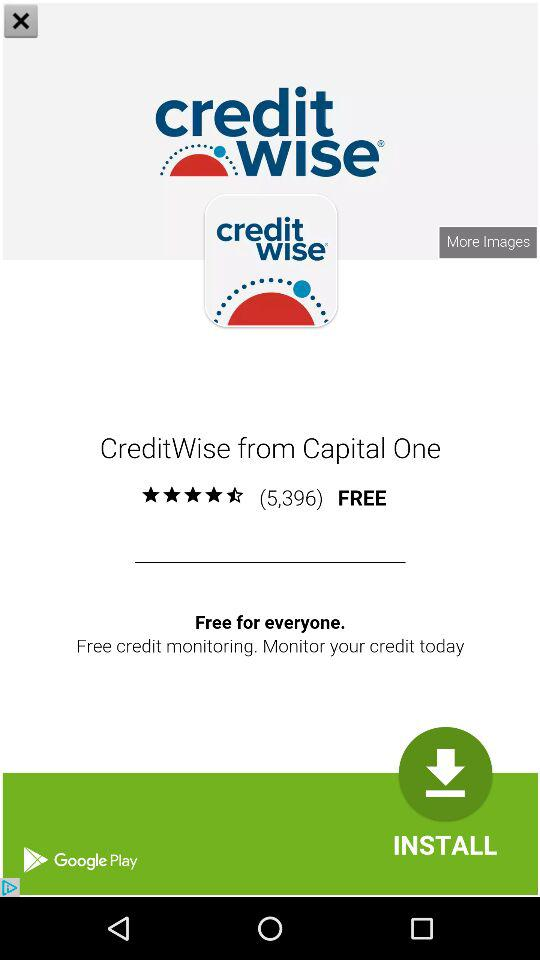Is the "CreditWise" application free or not? The application "CreditWise" is free. 